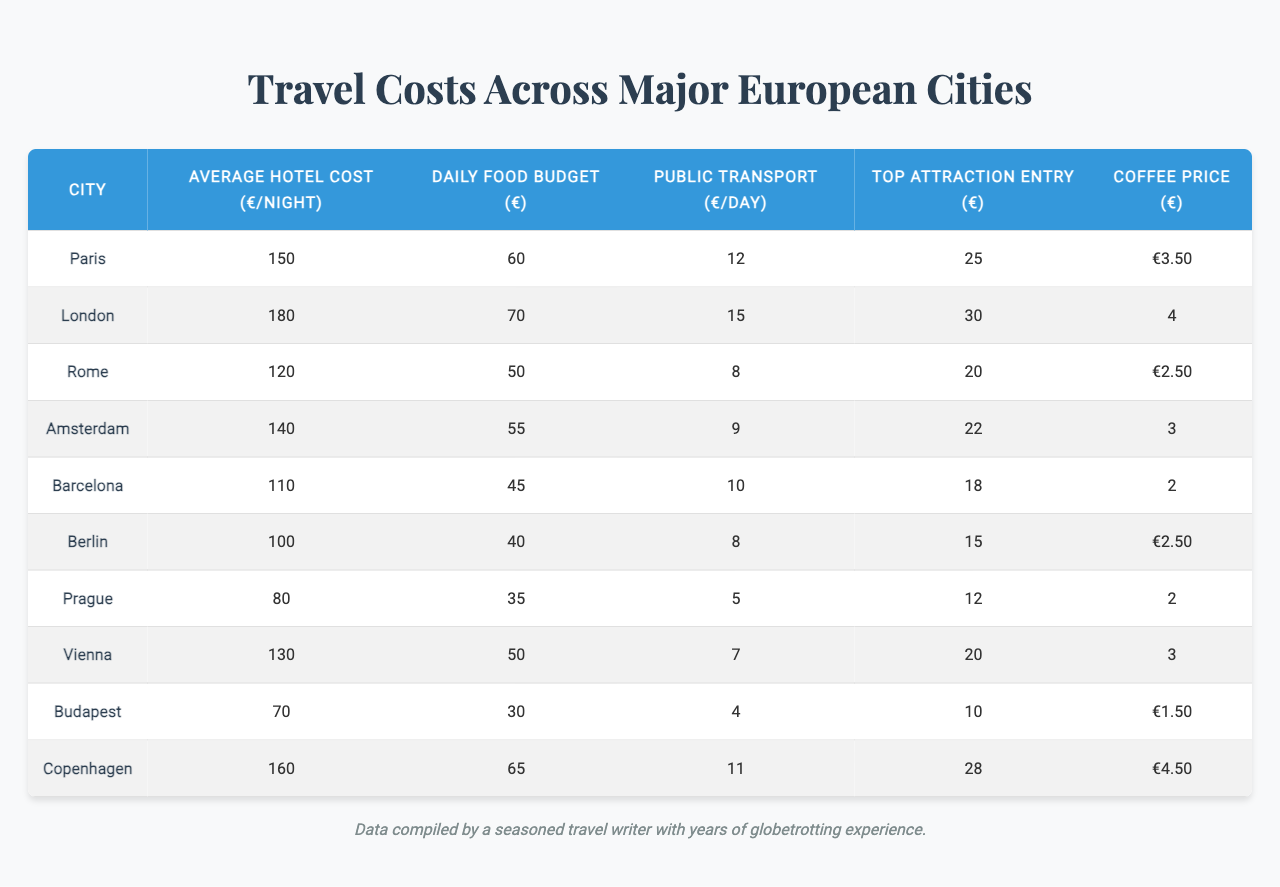What is the average hotel cost per night in London? The table lists the average hotel cost for London as €180 per night.
Answer: €180 What is the daily food budget in Prague? The daily food budget for Prague is provided in the table as €35.
Answer: €35 Which city has the highest public transport cost per day? London has the highest public transport cost listed in the table at €15 per day.
Answer: London What is the difference in average hotel costs between Paris and Berlin? The average hotel cost in Paris is €150, and in Berlin, it is €100; therefore, the difference is €150 - €100 = €50.
Answer: €50 What is the total daily budget (including hotel, food, and transport) for staying in Amsterdam? The total is calculated by adding the average hotel cost (€140), daily food budget (€55), and public transport (€9): €140 + €55 + €9 = €204.
Answer: €204 Is the coffee price in Barcelona lower than in Berlin? The coffee price in Barcelona is €2, and in Berlin, it is €2.5; hence, it is false that Barcelona's coffee price is lower.
Answer: No Which city offers the most affordable overall daily budget including hotel, food, and transport? The total budget must be calculated for all cities. For Budapest: €70 + €30 + €4 = €104 is the lowest compared to others.
Answer: Budapest If one were to visit the top attraction in Copenhagen, how much would it cost? The entry for the top attraction in Copenhagen is listed in the table as €28.
Answer: €28 What is the average cost of coffee across all cities listed? To find the average coffee price, sum all coffee prices (€3.5 + €4 + €2.5 + €3 + €2 + €2.5 + €2 + €3 + €1.5 + €4.5) = €25, then divide by the number of cities (10): €25/10 = €2.5.
Answer: €2.5 Which city's top attraction entry fee is closest to the average attraction entry fee of all cities? The entrance fees are €25 (Paris), €30 (London), €20 (Rome), €22 (Amsterdam), €18 (Barcelona), €15 (Berlin), €12 (Prague), €20 (Vienna), €10 (Budapest), €28 (Copenhagen). The average is €20.5, making Vienna's fee of €20 the closest.
Answer: Vienna 